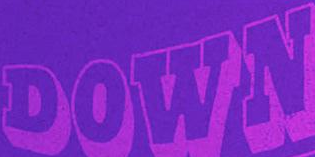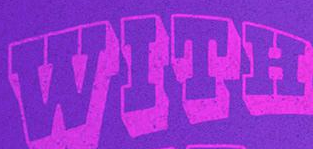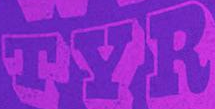Transcribe the words shown in these images in order, separated by a semicolon. DOWN; WITH; TYR 